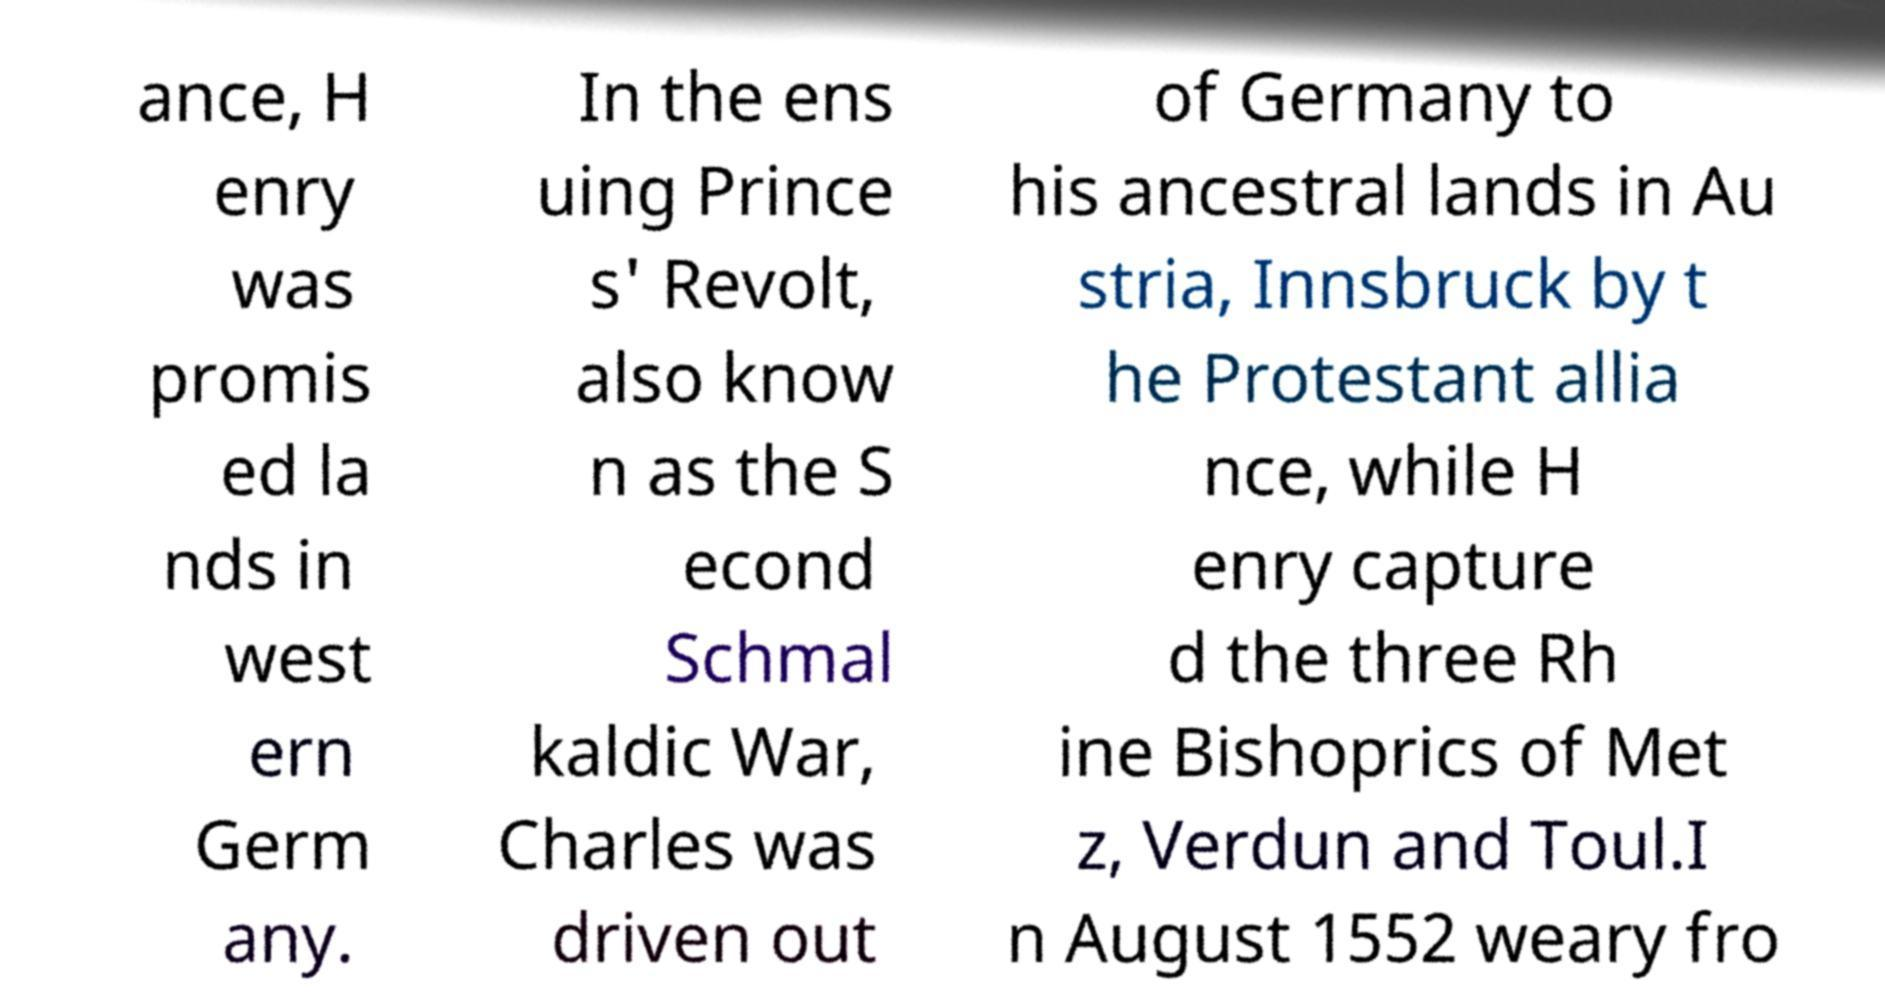I need the written content from this picture converted into text. Can you do that? ance, H enry was promis ed la nds in west ern Germ any. In the ens uing Prince s' Revolt, also know n as the S econd Schmal kaldic War, Charles was driven out of Germany to his ancestral lands in Au stria, Innsbruck by t he Protestant allia nce, while H enry capture d the three Rh ine Bishoprics of Met z, Verdun and Toul.I n August 1552 weary fro 